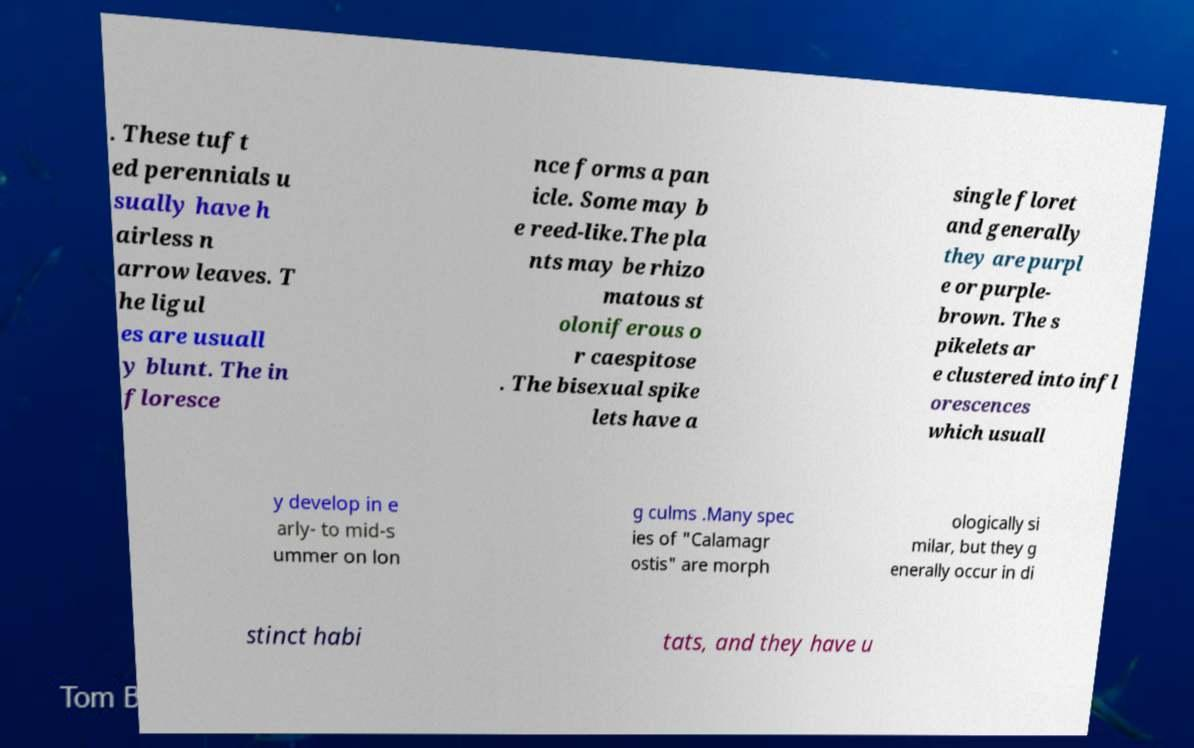Can you accurately transcribe the text from the provided image for me? . These tuft ed perennials u sually have h airless n arrow leaves. T he ligul es are usuall y blunt. The in floresce nce forms a pan icle. Some may b e reed-like.The pla nts may be rhizo matous st oloniferous o r caespitose . The bisexual spike lets have a single floret and generally they are purpl e or purple- brown. The s pikelets ar e clustered into infl orescences which usuall y develop in e arly- to mid-s ummer on lon g culms .Many spec ies of "Calamagr ostis" are morph ologically si milar, but they g enerally occur in di stinct habi tats, and they have u 